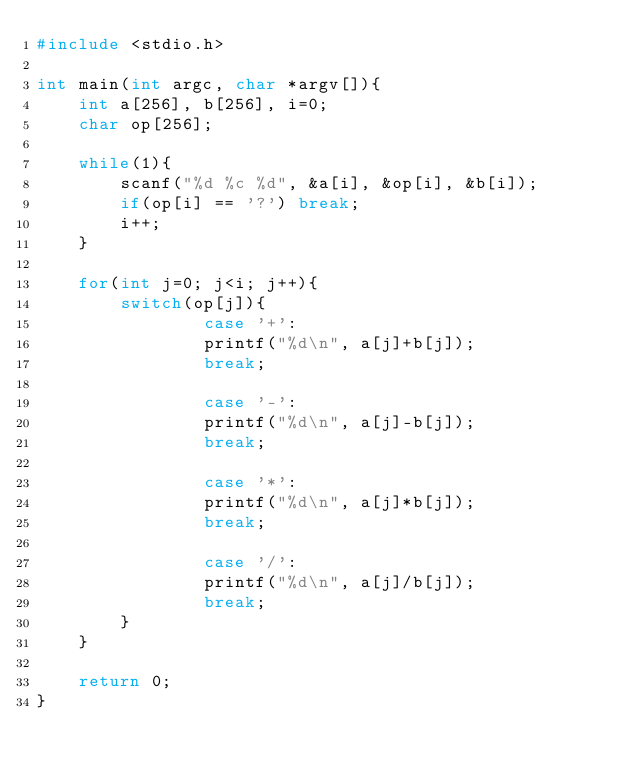<code> <loc_0><loc_0><loc_500><loc_500><_C_>#include <stdio.h>

int main(int argc, char *argv[]){
    int a[256], b[256], i=0;
    char op[256];
    
    while(1){
        scanf("%d %c %d", &a[i], &op[i], &b[i]);
        if(op[i] == '?') break;
        i++;
    }
    
    for(int j=0; j<i; j++){
        switch(op[j]){
                case '+':
                printf("%d\n", a[j]+b[j]);
                break;
                
                case '-':
                printf("%d\n", a[j]-b[j]);
                break;
                
                case '*':
                printf("%d\n", a[j]*b[j]);
                break;
                
                case '/':
                printf("%d\n", a[j]/b[j]);
                break;
        }
    }
    
    return 0;
}</code> 